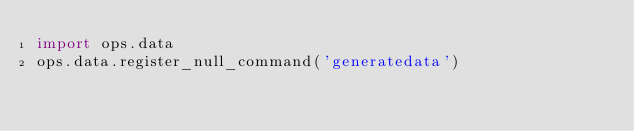<code> <loc_0><loc_0><loc_500><loc_500><_Python_>import ops.data
ops.data.register_null_command('generatedata')</code> 